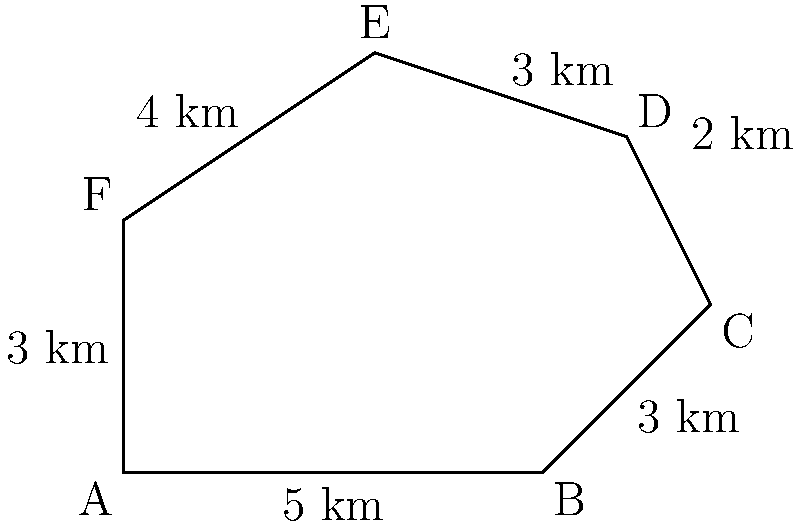A sustainable solar farm project has an irregularly shaped boundary as shown in the figure. The sides of the solar farm measure 5 km, 3 km, 2 km, 3 km, 4 km, and 3 km in clockwise order. Calculate the area of the solar farm using the shoelace formula. Round your answer to the nearest whole square kilometer. To calculate the area of this irregular polygon, we can use the shoelace formula:

$$ \text{Area} = \frac{1}{2}|\sum_{i=1}^{n} (x_i y_{i+1} - x_{i+1} y_i)| $$

Where $(x_i, y_i)$ are the coordinates of each vertex, and $(x_{n+1}, y_{n+1}) = (x_1, y_1)$.

Let's assign coordinates to each vertex:
A (0,0), B (5,0), C (7,2), D (6,4), E (3,5), F (0,3)

Now, let's apply the formula:

$$ \begin{align*}
\text{Area} &= \frac{1}{2}|(0 \cdot 0 - 5 \cdot 0) + (5 \cdot 2 - 7 \cdot 0) + (7 \cdot 4 - 6 \cdot 2) \\
&+ (6 \cdot 5 - 3 \cdot 4) + (3 \cdot 3 - 0 \cdot 5) + (0 \cdot 0 - 0 \cdot 3)| \\
&= \frac{1}{2}|(0) + (10) + (16) + (18) + (9) + (0)| \\
&= \frac{1}{2}(53) \\
&= 26.5 \text{ km}^2
\end{align*} $$

Rounding to the nearest whole square kilometer:

$$ 26.5 \text{ km}^2 \approx 27 \text{ km}^2 $$
Answer: 27 km² 